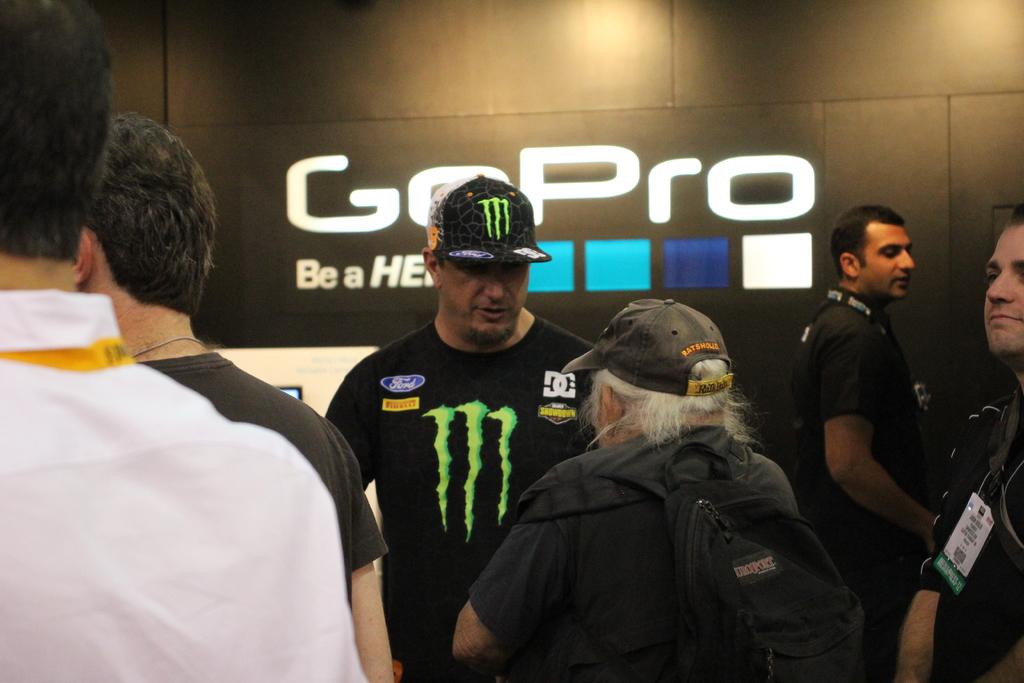What camera is mentioned on the wall in the back?
Make the answer very short. Gopro. What is the motto for gopro?
Offer a very short reply. Be a hero. 